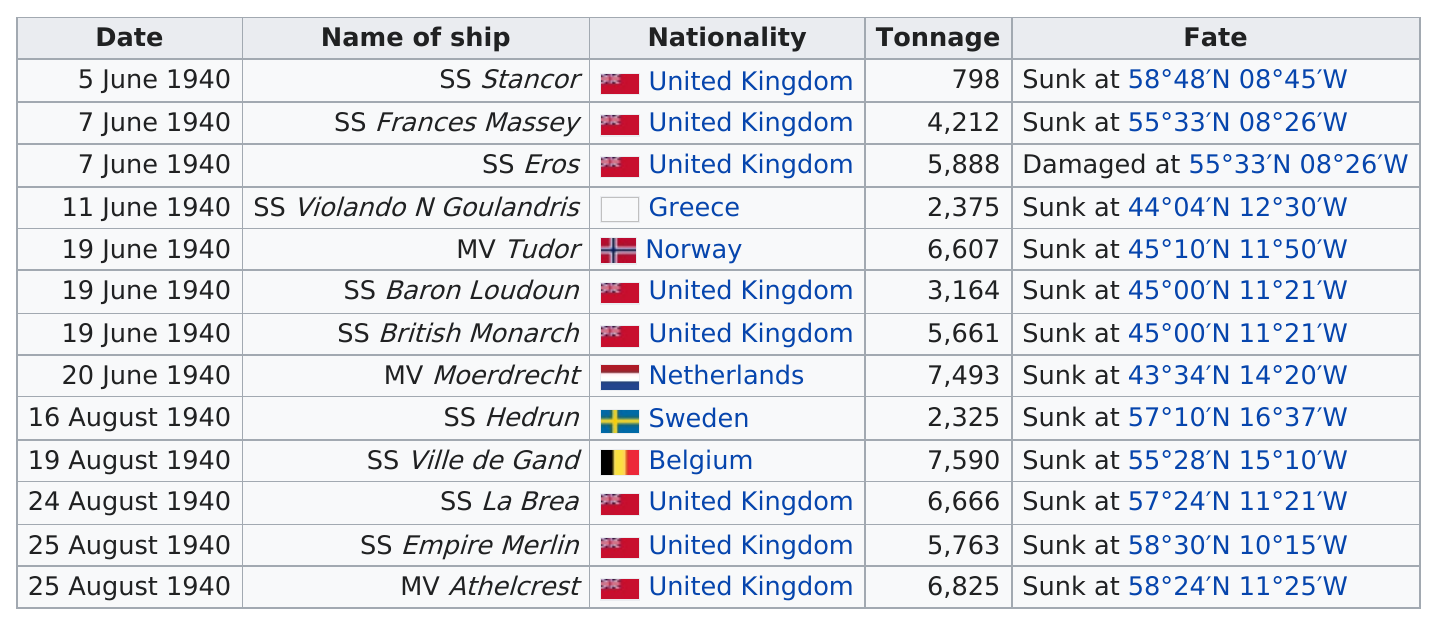Give some essential details in this illustration. On February 21, 1918, the SS Frances Massey was recorded as being sunk before the SS Erö, the first ship to be sunk by a U-boat using the newly developed "T-mode" torpedo. Out of the ships that had a tonnage greater than 7,000, two of them had more than that amount. The SS Ville de Gand was the ship with the largest tonnage. The difference in tonnage between the heaviest and lightest ships is 6792. The ships that share the same nationality as the SS Stancor are the SS Frances Massey, SS Eros, SS Baron Loudoun, SS British Monarch, SS La Brea, SS Empire Merlin, and MV Athelcrest. 